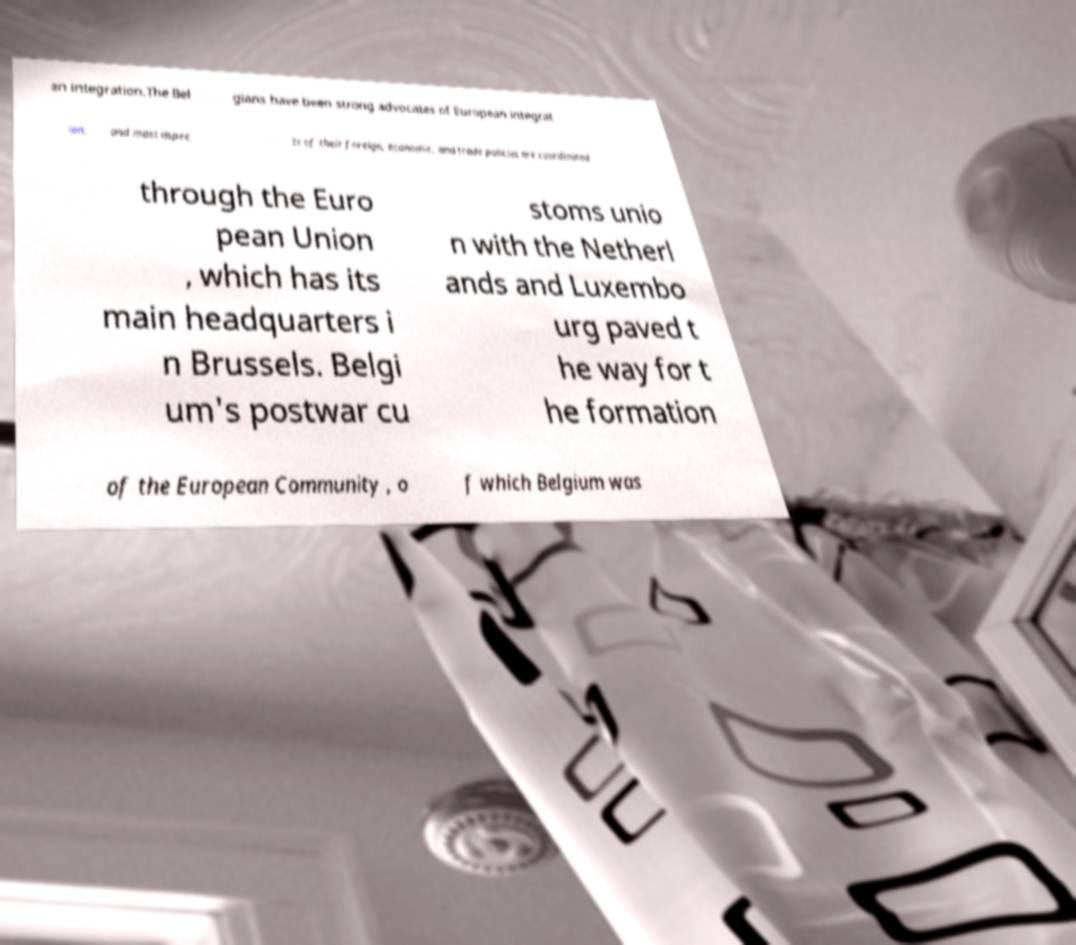There's text embedded in this image that I need extracted. Can you transcribe it verbatim? an integration.The Bel gians have been strong advocates of European integrat ion, and most aspec ts of their foreign, economic, and trade policies are coordinated through the Euro pean Union , which has its main headquarters i n Brussels. Belgi um's postwar cu stoms unio n with the Netherl ands and Luxembo urg paved t he way for t he formation of the European Community , o f which Belgium was 